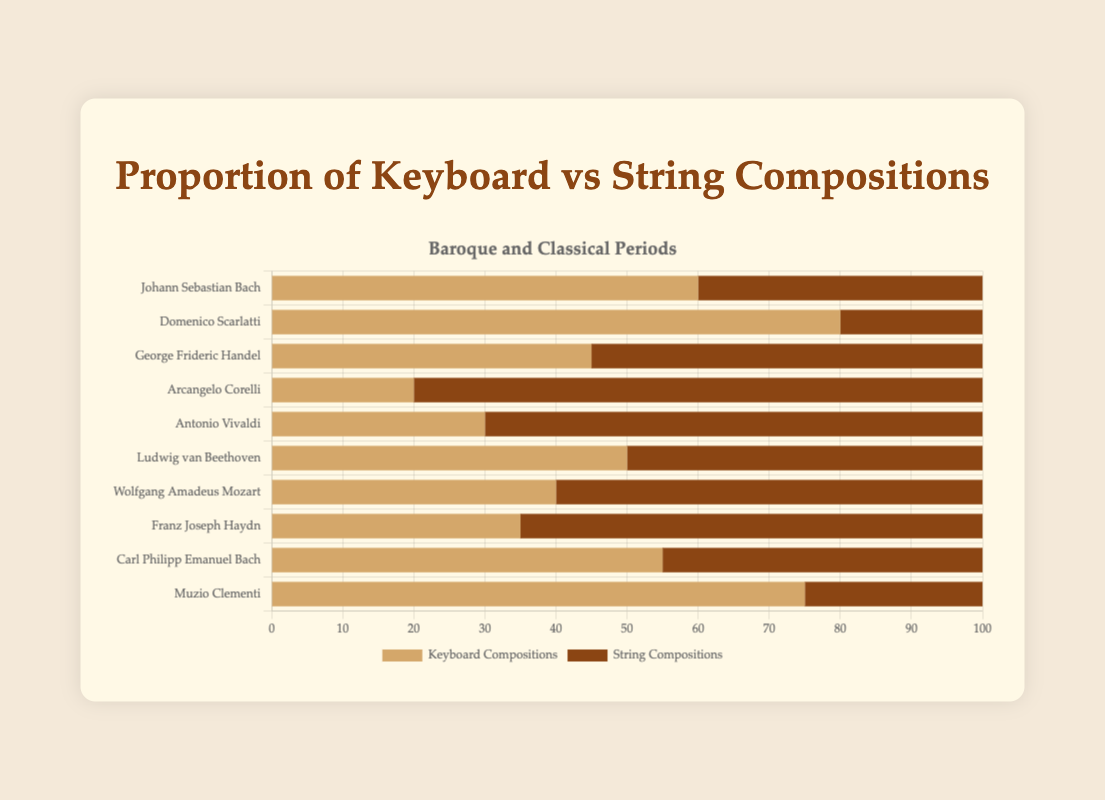Which composer has the highest proportion of keyboard compositions? Domenico Scarlatti has the highest proportion of keyboard compositions with 80 out of 100 total compositions, which makes up 80%.
Answer: Domenico Scarlatti Which composer has an equal number of keyboard and string compositions? Ludwig van Beethoven has equal numbers of keyboard and string compositions, each being 50.
Answer: Ludwig van Beethoven Who has more string compositions, George Frideric Handel or Wolfgang Amadeus Mozart? George Frideric Handel has 55 string compositions while Wolfgang Amadeus Mozart has 60 string compositions. Therefore, Wolfgang Amadeus Mozart has more string compositions.
Answer: Wolfgang Amadeus Mozart Compare the total number of compositions by Johann Sebastian Bach with that of Carl Philipp Emanuel Bach. Who composed more? Johann Sebastian Bach has a total of 60 (keyboard) + 40 (string) = 100 compositions. Carl Philipp Emanuel Bach has 55 (keyboard) + 45 (string) = 100 compositions. Both have composed an equal number of compositions.
Answer: Both have composed an equal number Which Classical period composer has the highest proportion of keyboard compositions? Muzio Clementi has the highest proportion of keyboard compositions among Classical period composers, with 75 out of 100 total compositions, making up 75%.
Answer: Muzio Clementi What is the average proportion of string compositions for Baroque period composers? The string compositions for Baroque composers are: 40, 20, 55, 80, and 70. The total is 40 + 20 + 55 + 80 + 70 = 265. There are 5 composers, so the average proportion is 265 / 5 = 53%.
Answer: 53% Who has fewer keyboard compositions, Arcangelo Corelli or Franz Joseph Haydn? Arcangelo Corelli has 20 keyboard compositions while Franz Joseph Haydn has 35 keyboard compositions. Therefore, Arcangelo Corelli has fewer keyboard compositions.
Answer: Arcangelo Corelli Which composer has the highest total number of compositions? Johann Sebastian Bach and Carl Philipp Emanuel Bach both have the highest total number of compositions with 100 each.
Answer: Johann Sebastian Bach and Carl Philipp Emanuel Bach On average, do composers from the Baroque period or the Classical period have more keyboard compositions? For Baroque composers: (60 + 80 + 45 + 20 + 30) / 5 = 47. For Classical composers: (50 + 40 + 35 + 55 + 75) / 5 = 51. On average, composers from the Classical period have more keyboard compositions.
Answer: Classical period 